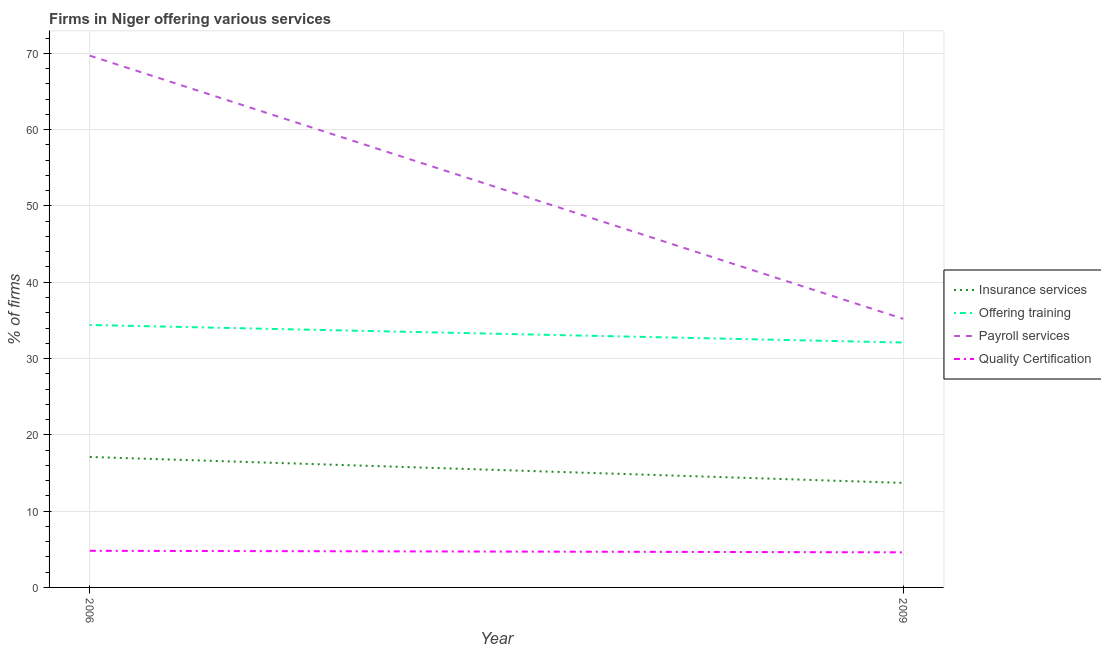How many different coloured lines are there?
Your answer should be very brief. 4. Is the number of lines equal to the number of legend labels?
Offer a very short reply. Yes. What is the percentage of firms offering training in 2009?
Your answer should be compact. 32.1. Across all years, what is the maximum percentage of firms offering training?
Make the answer very short. 34.4. Across all years, what is the minimum percentage of firms offering payroll services?
Provide a succinct answer. 35.2. In which year was the percentage of firms offering training maximum?
Your answer should be compact. 2006. In which year was the percentage of firms offering training minimum?
Offer a terse response. 2009. What is the total percentage of firms offering payroll services in the graph?
Your response must be concise. 104.9. What is the difference between the percentage of firms offering payroll services in 2006 and that in 2009?
Offer a very short reply. 34.5. What is the difference between the percentage of firms offering quality certification in 2009 and the percentage of firms offering insurance services in 2006?
Offer a very short reply. -12.5. What is the average percentage of firms offering insurance services per year?
Make the answer very short. 15.4. In the year 2006, what is the difference between the percentage of firms offering training and percentage of firms offering quality certification?
Provide a short and direct response. 29.6. What is the ratio of the percentage of firms offering quality certification in 2006 to that in 2009?
Offer a very short reply. 1.04. Is the percentage of firms offering training in 2006 less than that in 2009?
Give a very brief answer. No. In how many years, is the percentage of firms offering payroll services greater than the average percentage of firms offering payroll services taken over all years?
Give a very brief answer. 1. Is the percentage of firms offering training strictly greater than the percentage of firms offering quality certification over the years?
Your answer should be very brief. Yes. How many lines are there?
Your answer should be very brief. 4. How many years are there in the graph?
Your answer should be very brief. 2. Are the values on the major ticks of Y-axis written in scientific E-notation?
Make the answer very short. No. Does the graph contain grids?
Ensure brevity in your answer.  Yes. Where does the legend appear in the graph?
Make the answer very short. Center right. What is the title of the graph?
Your answer should be very brief. Firms in Niger offering various services . Does "Salary of employees" appear as one of the legend labels in the graph?
Your response must be concise. No. What is the label or title of the Y-axis?
Provide a short and direct response. % of firms. What is the % of firms in Insurance services in 2006?
Offer a very short reply. 17.1. What is the % of firms of Offering training in 2006?
Give a very brief answer. 34.4. What is the % of firms in Payroll services in 2006?
Provide a succinct answer. 69.7. What is the % of firms of Insurance services in 2009?
Your answer should be compact. 13.7. What is the % of firms of Offering training in 2009?
Your answer should be compact. 32.1. What is the % of firms in Payroll services in 2009?
Your response must be concise. 35.2. Across all years, what is the maximum % of firms of Insurance services?
Your answer should be compact. 17.1. Across all years, what is the maximum % of firms in Offering training?
Offer a terse response. 34.4. Across all years, what is the maximum % of firms in Payroll services?
Make the answer very short. 69.7. Across all years, what is the minimum % of firms in Insurance services?
Provide a succinct answer. 13.7. Across all years, what is the minimum % of firms in Offering training?
Your response must be concise. 32.1. Across all years, what is the minimum % of firms in Payroll services?
Make the answer very short. 35.2. Across all years, what is the minimum % of firms in Quality Certification?
Keep it short and to the point. 4.6. What is the total % of firms in Insurance services in the graph?
Keep it short and to the point. 30.8. What is the total % of firms of Offering training in the graph?
Your response must be concise. 66.5. What is the total % of firms of Payroll services in the graph?
Ensure brevity in your answer.  104.9. What is the total % of firms of Quality Certification in the graph?
Give a very brief answer. 9.4. What is the difference between the % of firms of Insurance services in 2006 and that in 2009?
Offer a very short reply. 3.4. What is the difference between the % of firms in Payroll services in 2006 and that in 2009?
Ensure brevity in your answer.  34.5. What is the difference between the % of firms in Quality Certification in 2006 and that in 2009?
Provide a short and direct response. 0.2. What is the difference between the % of firms in Insurance services in 2006 and the % of firms in Payroll services in 2009?
Make the answer very short. -18.1. What is the difference between the % of firms of Insurance services in 2006 and the % of firms of Quality Certification in 2009?
Provide a succinct answer. 12.5. What is the difference between the % of firms in Offering training in 2006 and the % of firms in Quality Certification in 2009?
Your answer should be very brief. 29.8. What is the difference between the % of firms in Payroll services in 2006 and the % of firms in Quality Certification in 2009?
Give a very brief answer. 65.1. What is the average % of firms of Insurance services per year?
Provide a succinct answer. 15.4. What is the average % of firms in Offering training per year?
Your response must be concise. 33.25. What is the average % of firms in Payroll services per year?
Offer a very short reply. 52.45. What is the average % of firms of Quality Certification per year?
Keep it short and to the point. 4.7. In the year 2006, what is the difference between the % of firms in Insurance services and % of firms in Offering training?
Provide a short and direct response. -17.3. In the year 2006, what is the difference between the % of firms of Insurance services and % of firms of Payroll services?
Provide a short and direct response. -52.6. In the year 2006, what is the difference between the % of firms in Insurance services and % of firms in Quality Certification?
Give a very brief answer. 12.3. In the year 2006, what is the difference between the % of firms of Offering training and % of firms of Payroll services?
Your answer should be compact. -35.3. In the year 2006, what is the difference between the % of firms of Offering training and % of firms of Quality Certification?
Ensure brevity in your answer.  29.6. In the year 2006, what is the difference between the % of firms of Payroll services and % of firms of Quality Certification?
Provide a succinct answer. 64.9. In the year 2009, what is the difference between the % of firms in Insurance services and % of firms in Offering training?
Offer a terse response. -18.4. In the year 2009, what is the difference between the % of firms of Insurance services and % of firms of Payroll services?
Provide a succinct answer. -21.5. In the year 2009, what is the difference between the % of firms of Offering training and % of firms of Quality Certification?
Give a very brief answer. 27.5. In the year 2009, what is the difference between the % of firms in Payroll services and % of firms in Quality Certification?
Provide a short and direct response. 30.6. What is the ratio of the % of firms in Insurance services in 2006 to that in 2009?
Offer a very short reply. 1.25. What is the ratio of the % of firms of Offering training in 2006 to that in 2009?
Your response must be concise. 1.07. What is the ratio of the % of firms in Payroll services in 2006 to that in 2009?
Provide a short and direct response. 1.98. What is the ratio of the % of firms in Quality Certification in 2006 to that in 2009?
Your response must be concise. 1.04. What is the difference between the highest and the second highest % of firms in Insurance services?
Make the answer very short. 3.4. What is the difference between the highest and the second highest % of firms in Offering training?
Offer a terse response. 2.3. What is the difference between the highest and the second highest % of firms of Payroll services?
Your response must be concise. 34.5. What is the difference between the highest and the second highest % of firms of Quality Certification?
Give a very brief answer. 0.2. What is the difference between the highest and the lowest % of firms in Offering training?
Provide a short and direct response. 2.3. What is the difference between the highest and the lowest % of firms in Payroll services?
Make the answer very short. 34.5. What is the difference between the highest and the lowest % of firms in Quality Certification?
Your response must be concise. 0.2. 